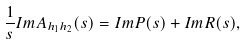Convert formula to latex. <formula><loc_0><loc_0><loc_500><loc_500>\frac { 1 } { s } I m A _ { h _ { 1 } h _ { 2 } } ( s ) = I m P ( s ) + I m R ( s ) ,</formula> 